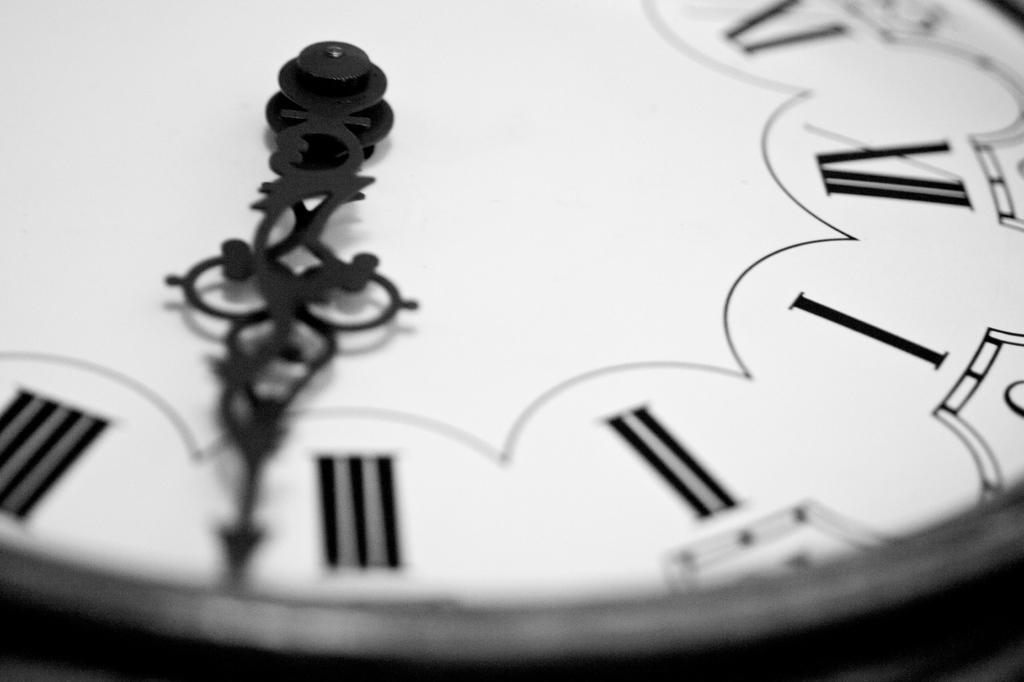<image>
Relay a brief, clear account of the picture shown. A close up of a clock with Roman numerals shows the hands of the clock to be just past the 3. 